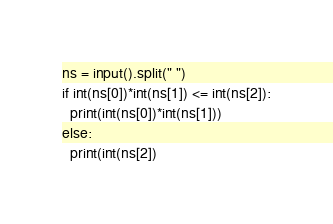Convert code to text. <code><loc_0><loc_0><loc_500><loc_500><_Python_>ns = input().split(" ")
if int(ns[0])*int(ns[1]) <= int(ns[2]):
  print(int(ns[0])*int(ns[1]))
else:
  print(int(ns[2])</code> 